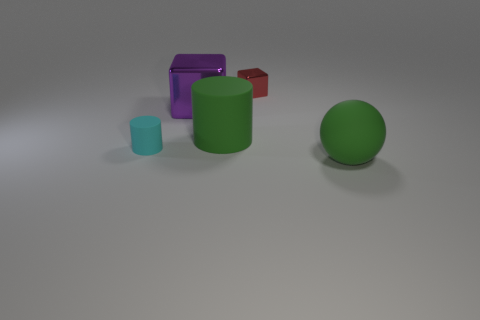Add 1 tiny cyan rubber things. How many objects exist? 6 Subtract all spheres. How many objects are left? 4 Add 5 large green rubber things. How many large green rubber things exist? 7 Subtract 0 gray blocks. How many objects are left? 5 Subtract all green objects. Subtract all small blue shiny objects. How many objects are left? 3 Add 2 tiny blocks. How many tiny blocks are left? 3 